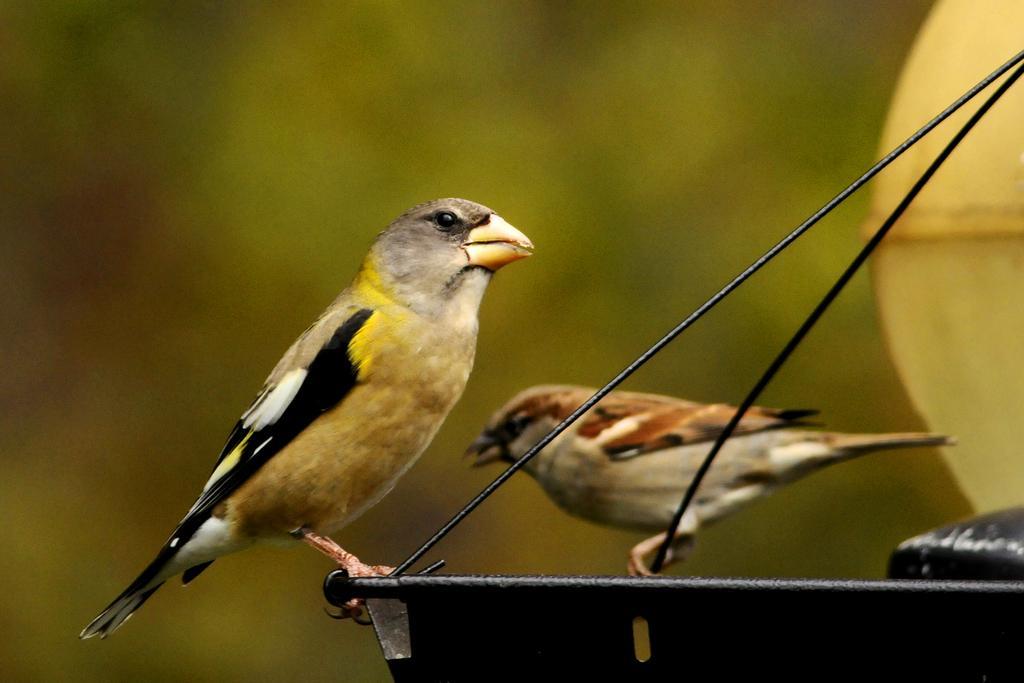Please provide a concise description of this image. In this image two birds are standing on a metal object. Right side there is an object. Background is blurry. 